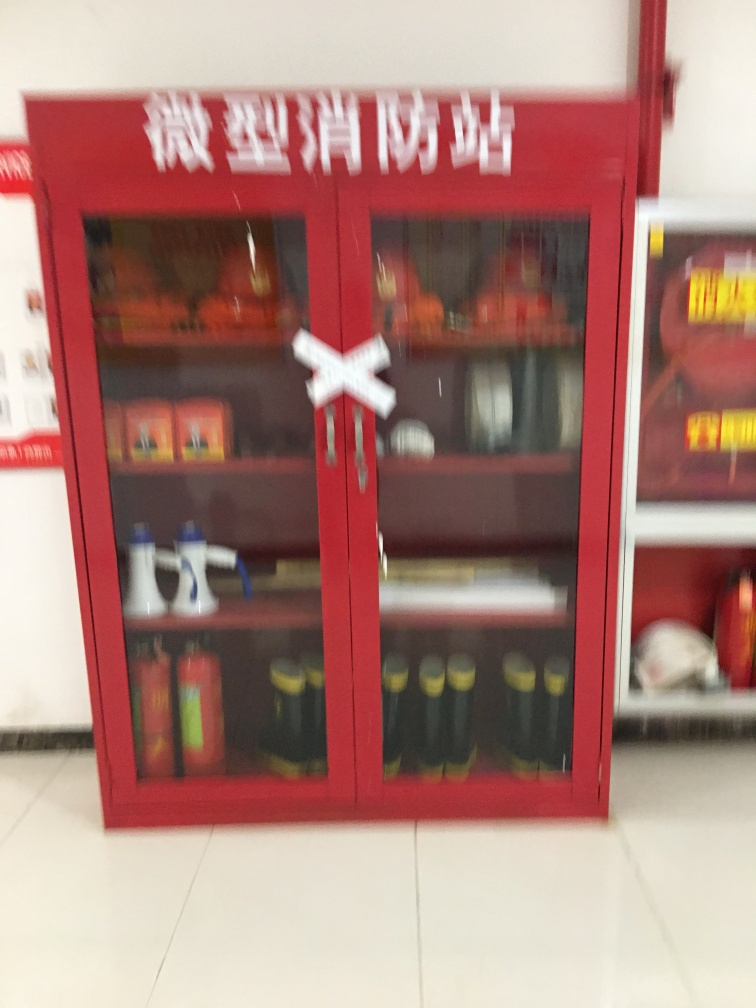Could you provide more information about the items stored in the fire station? Certainly! Within the fire station cabinet, we can see what appears to be standard firefighting equipment. This includes hoses, nozzles, a fire extinguisher, and possibly some personal protective gear. The exact details are hard to discern due to the blurred nature of the image. 